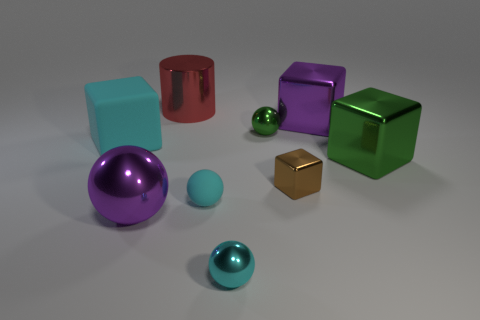Subtract all large blocks. How many blocks are left? 1 Subtract all red cylinders. How many cyan spheres are left? 2 Subtract all green balls. How many balls are left? 3 Subtract 1 spheres. How many spheres are left? 3 Subtract all cylinders. How many objects are left? 8 Subtract all purple metallic blocks. Subtract all brown blocks. How many objects are left? 7 Add 2 small cyan things. How many small cyan things are left? 4 Add 8 large purple things. How many large purple things exist? 10 Subtract 0 gray cylinders. How many objects are left? 9 Subtract all purple blocks. Subtract all red cylinders. How many blocks are left? 3 